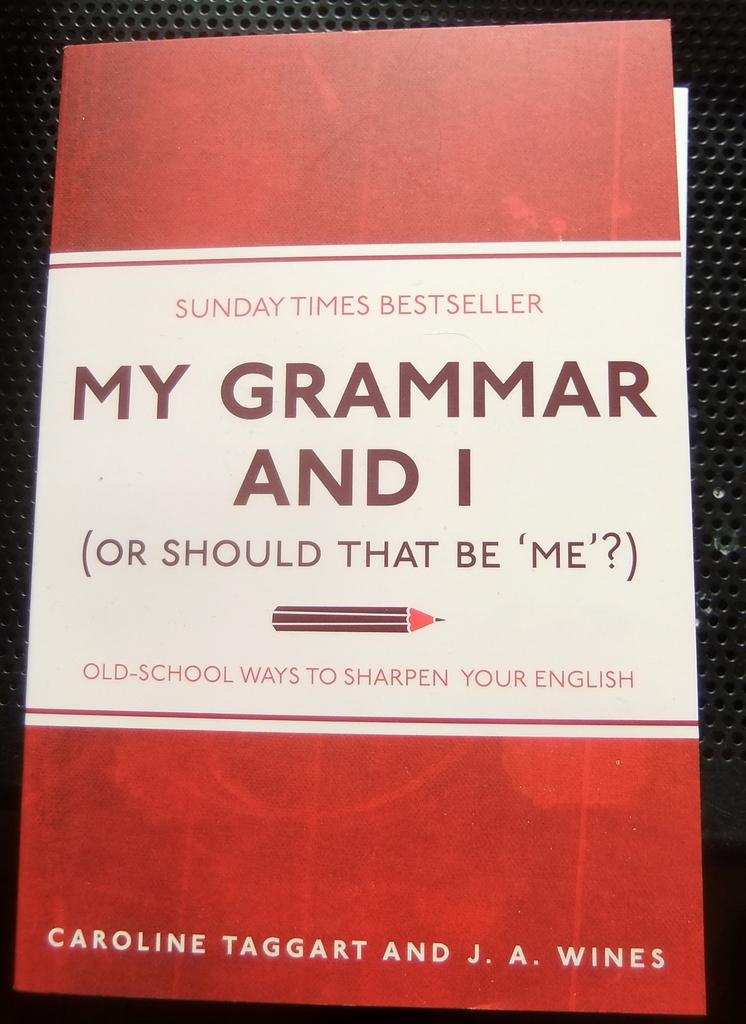Provide a one-sentence caption for the provided image. A book cover of a book titled My Grammar and I is red and white. 